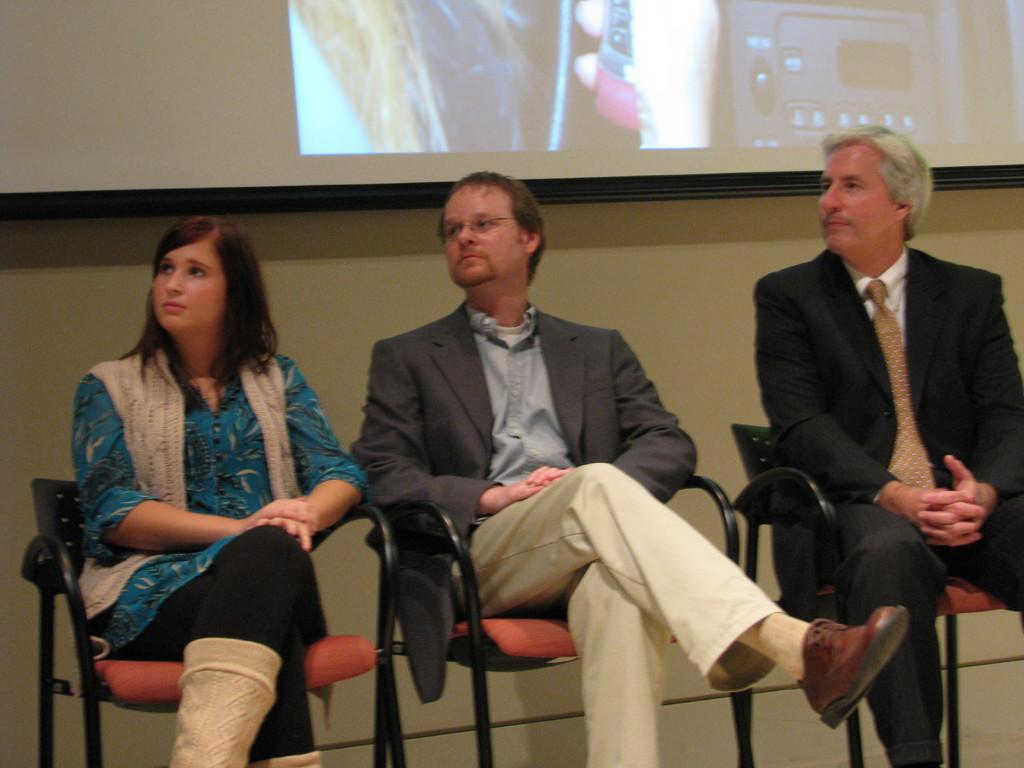Can you describe this image briefly? In this picture I can see three persons sitting on the chairs, and in the background there is a projector screen and a wall. 